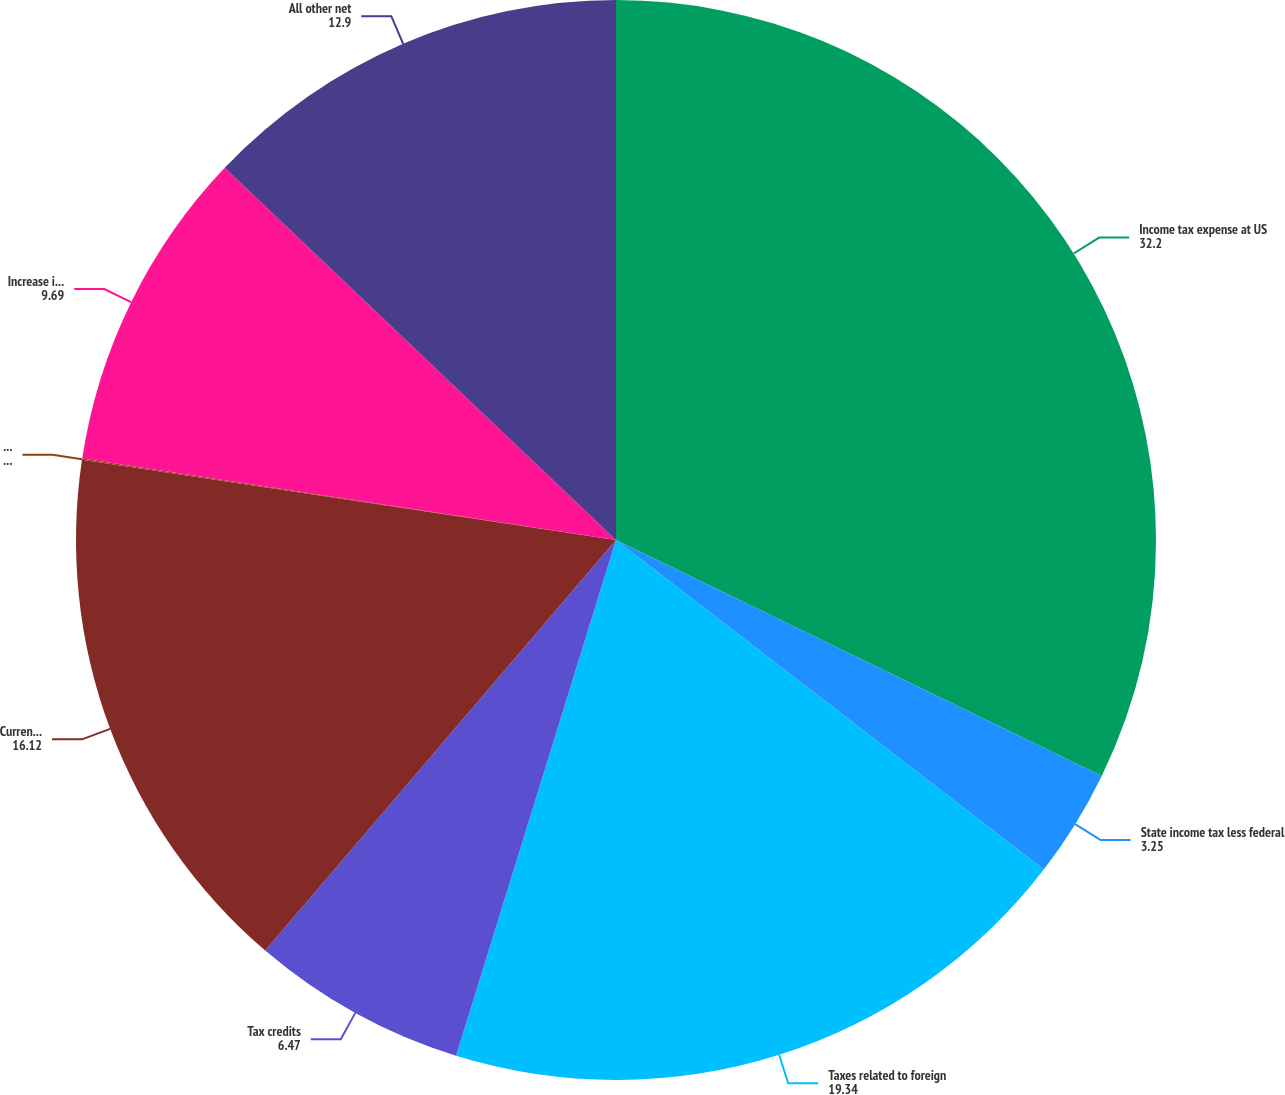Convert chart. <chart><loc_0><loc_0><loc_500><loc_500><pie_chart><fcel>Income tax expense at US<fcel>State income tax less federal<fcel>Taxes related to foreign<fcel>Tax credits<fcel>Current and deferred taxes<fcel>Net change in tax<fcel>Increase in valuation<fcel>All other net<nl><fcel>32.2%<fcel>3.25%<fcel>19.34%<fcel>6.47%<fcel>16.12%<fcel>0.04%<fcel>9.69%<fcel>12.9%<nl></chart> 